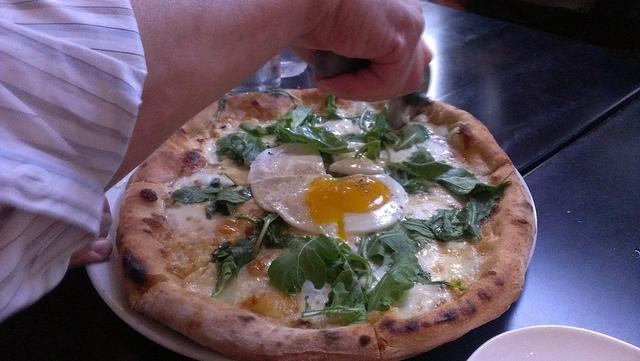What animal did the topmost ingredient come from?
From the following set of four choices, select the accurate answer to respond to the question.
Options: Cow, pig, chicken, fish. Chicken. What kind of bird created something that sits on this pizza?
Choose the correct response, then elucidate: 'Answer: answer
Rationale: rationale.'
Options: Quail, sparrow, chicken, ostrich. Answer: chicken.
Rationale: There is an egg in the middle of the pizza, and birds are known to lay eggs. 